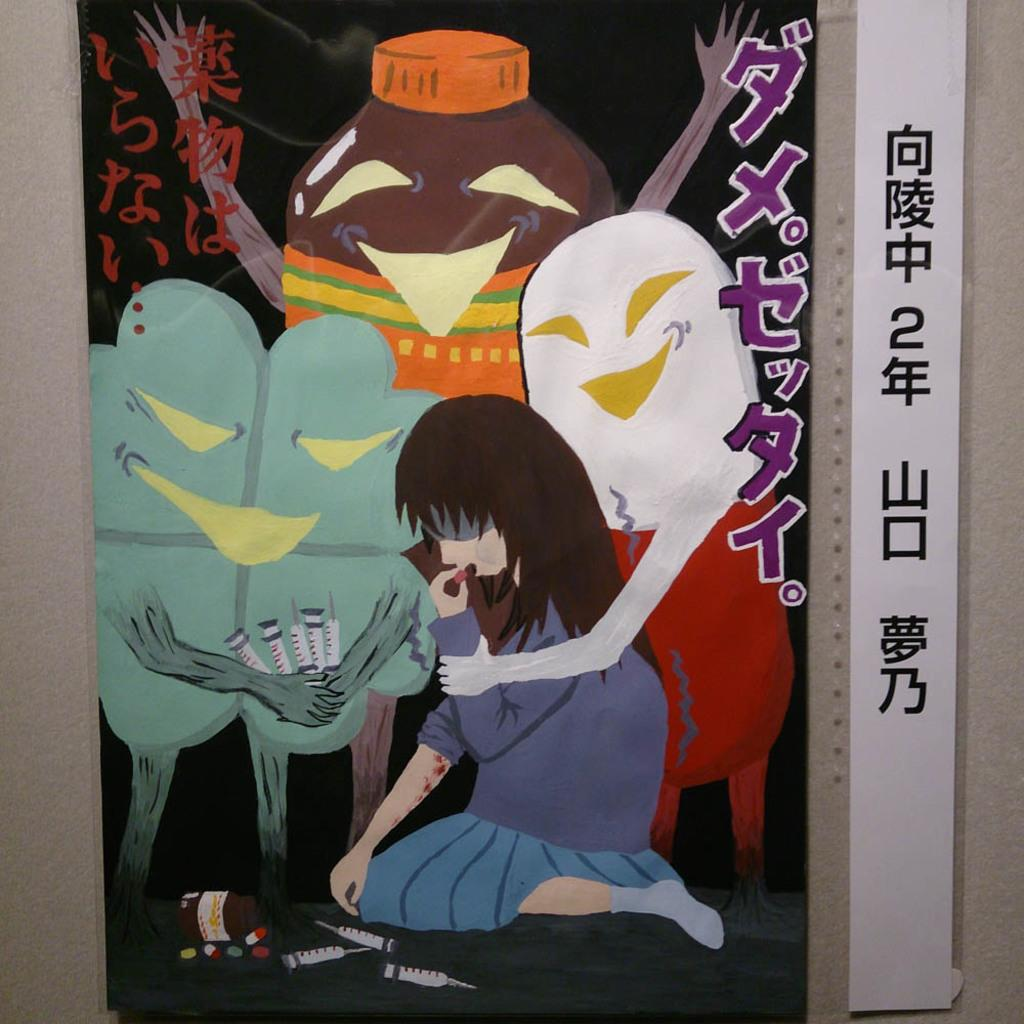What can be seen in the image? There is a poster in the image. Where is the poster located? The poster is on a surface. What type of whip is being used on the playground in the image? There is no playground or whip present in the image; it only features a poster on a surface. 